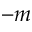<formula> <loc_0><loc_0><loc_500><loc_500>- m</formula> 